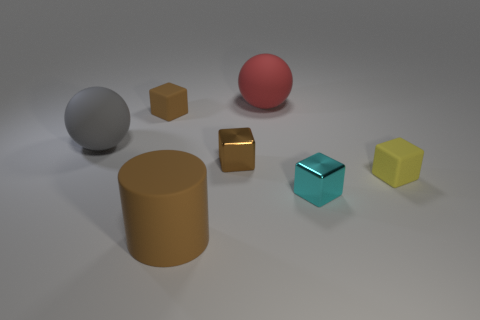Add 2 yellow matte blocks. How many objects exist? 9 Subtract all cubes. How many objects are left? 3 Subtract 0 green cylinders. How many objects are left? 7 Subtract all yellow matte cubes. Subtract all small brown rubber objects. How many objects are left? 5 Add 3 large brown rubber cylinders. How many large brown rubber cylinders are left? 4 Add 7 small blue objects. How many small blue objects exist? 7 